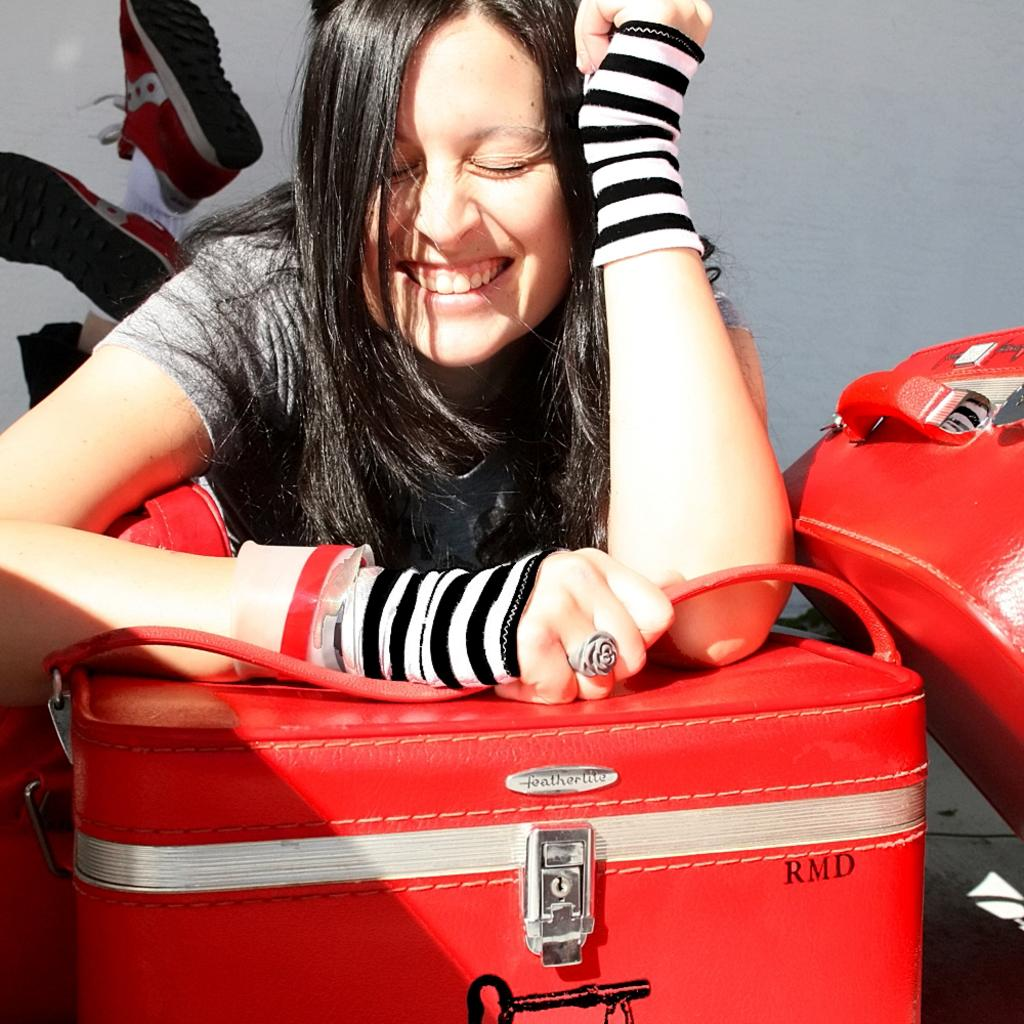Who is present in the image? There is a woman in the image. What is the woman doing in the image? The woman is smiling. What is the woman holding in the image? The woman is holding a red-colored suitcase handle. What type of disease is the woman suffering from in the image? There is no indication of any disease in the image; the woman is smiling and appears healthy. 